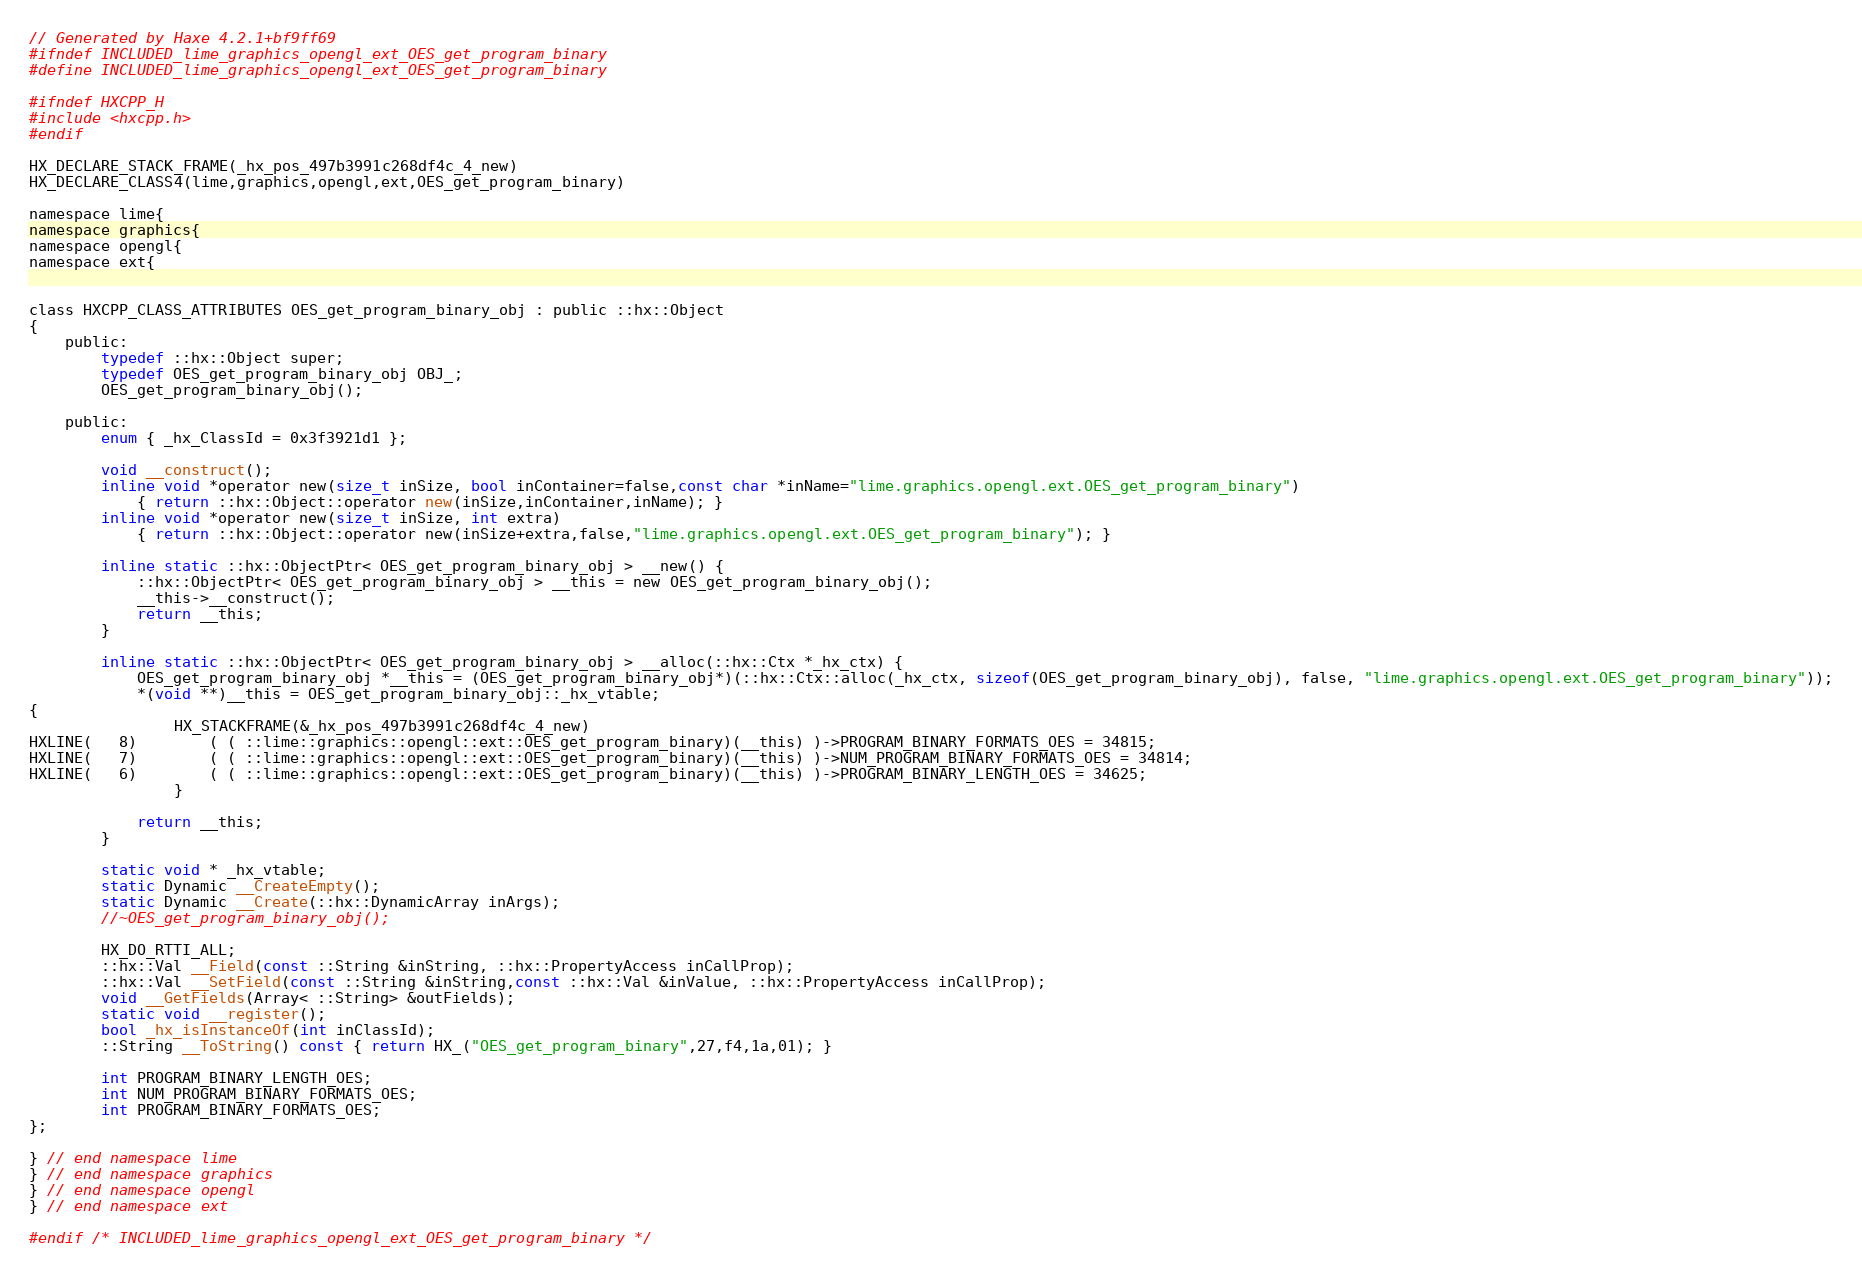Convert code to text. <code><loc_0><loc_0><loc_500><loc_500><_C_>// Generated by Haxe 4.2.1+bf9ff69
#ifndef INCLUDED_lime_graphics_opengl_ext_OES_get_program_binary
#define INCLUDED_lime_graphics_opengl_ext_OES_get_program_binary

#ifndef HXCPP_H
#include <hxcpp.h>
#endif

HX_DECLARE_STACK_FRAME(_hx_pos_497b3991c268df4c_4_new)
HX_DECLARE_CLASS4(lime,graphics,opengl,ext,OES_get_program_binary)

namespace lime{
namespace graphics{
namespace opengl{
namespace ext{


class HXCPP_CLASS_ATTRIBUTES OES_get_program_binary_obj : public ::hx::Object
{
	public:
		typedef ::hx::Object super;
		typedef OES_get_program_binary_obj OBJ_;
		OES_get_program_binary_obj();

	public:
		enum { _hx_ClassId = 0x3f3921d1 };

		void __construct();
		inline void *operator new(size_t inSize, bool inContainer=false,const char *inName="lime.graphics.opengl.ext.OES_get_program_binary")
			{ return ::hx::Object::operator new(inSize,inContainer,inName); }
		inline void *operator new(size_t inSize, int extra)
			{ return ::hx::Object::operator new(inSize+extra,false,"lime.graphics.opengl.ext.OES_get_program_binary"); }

		inline static ::hx::ObjectPtr< OES_get_program_binary_obj > __new() {
			::hx::ObjectPtr< OES_get_program_binary_obj > __this = new OES_get_program_binary_obj();
			__this->__construct();
			return __this;
		}

		inline static ::hx::ObjectPtr< OES_get_program_binary_obj > __alloc(::hx::Ctx *_hx_ctx) {
			OES_get_program_binary_obj *__this = (OES_get_program_binary_obj*)(::hx::Ctx::alloc(_hx_ctx, sizeof(OES_get_program_binary_obj), false, "lime.graphics.opengl.ext.OES_get_program_binary"));
			*(void **)__this = OES_get_program_binary_obj::_hx_vtable;
{
            	HX_STACKFRAME(&_hx_pos_497b3991c268df4c_4_new)
HXLINE(   8)		( ( ::lime::graphics::opengl::ext::OES_get_program_binary)(__this) )->PROGRAM_BINARY_FORMATS_OES = 34815;
HXLINE(   7)		( ( ::lime::graphics::opengl::ext::OES_get_program_binary)(__this) )->NUM_PROGRAM_BINARY_FORMATS_OES = 34814;
HXLINE(   6)		( ( ::lime::graphics::opengl::ext::OES_get_program_binary)(__this) )->PROGRAM_BINARY_LENGTH_OES = 34625;
            	}
		
			return __this;
		}

		static void * _hx_vtable;
		static Dynamic __CreateEmpty();
		static Dynamic __Create(::hx::DynamicArray inArgs);
		//~OES_get_program_binary_obj();

		HX_DO_RTTI_ALL;
		::hx::Val __Field(const ::String &inString, ::hx::PropertyAccess inCallProp);
		::hx::Val __SetField(const ::String &inString,const ::hx::Val &inValue, ::hx::PropertyAccess inCallProp);
		void __GetFields(Array< ::String> &outFields);
		static void __register();
		bool _hx_isInstanceOf(int inClassId);
		::String __ToString() const { return HX_("OES_get_program_binary",27,f4,1a,01); }

		int PROGRAM_BINARY_LENGTH_OES;
		int NUM_PROGRAM_BINARY_FORMATS_OES;
		int PROGRAM_BINARY_FORMATS_OES;
};

} // end namespace lime
} // end namespace graphics
} // end namespace opengl
} // end namespace ext

#endif /* INCLUDED_lime_graphics_opengl_ext_OES_get_program_binary */ 
</code> 